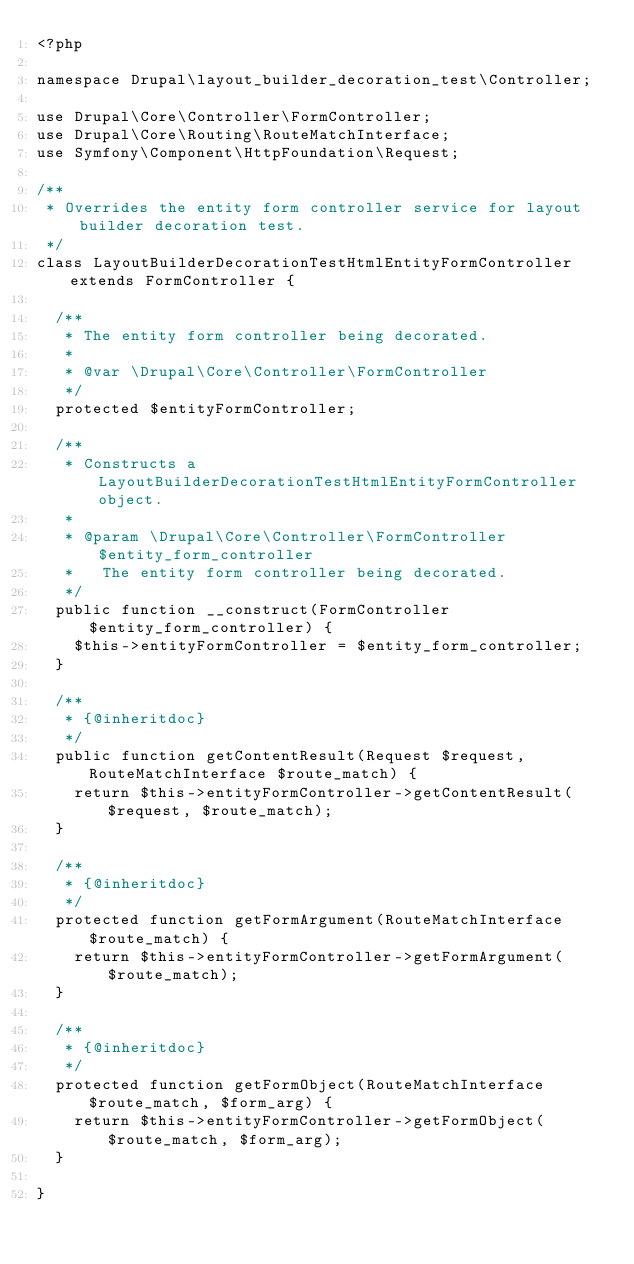Convert code to text. <code><loc_0><loc_0><loc_500><loc_500><_PHP_><?php

namespace Drupal\layout_builder_decoration_test\Controller;

use Drupal\Core\Controller\FormController;
use Drupal\Core\Routing\RouteMatchInterface;
use Symfony\Component\HttpFoundation\Request;

/**
 * Overrides the entity form controller service for layout builder decoration test.
 */
class LayoutBuilderDecorationTestHtmlEntityFormController extends FormController {

  /**
   * The entity form controller being decorated.
   *
   * @var \Drupal\Core\Controller\FormController
   */
  protected $entityFormController;

  /**
   * Constructs a LayoutBuilderDecorationTestHtmlEntityFormController object.
   *
   * @param \Drupal\Core\Controller\FormController $entity_form_controller
   *   The entity form controller being decorated.
   */
  public function __construct(FormController $entity_form_controller) {
    $this->entityFormController = $entity_form_controller;
  }

  /**
   * {@inheritdoc}
   */
  public function getContentResult(Request $request, RouteMatchInterface $route_match) {
    return $this->entityFormController->getContentResult($request, $route_match);
  }

  /**
   * {@inheritdoc}
   */
  protected function getFormArgument(RouteMatchInterface $route_match) {
    return $this->entityFormController->getFormArgument($route_match);
  }

  /**
   * {@inheritdoc}
   */
  protected function getFormObject(RouteMatchInterface $route_match, $form_arg) {
    return $this->entityFormController->getFormObject($route_match, $form_arg);
  }

}
</code> 